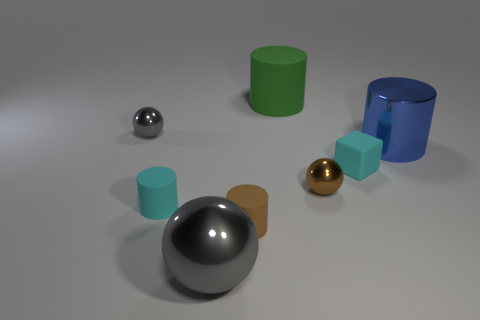What is the material of the green thing that is the same size as the metal cylinder?
Offer a very short reply. Rubber. Is there a brown metallic thing that has the same size as the brown cylinder?
Your answer should be very brief. Yes. Is the number of cyan blocks behind the small block less than the number of green cylinders?
Your answer should be compact. Yes. Are there fewer large objects that are behind the large rubber cylinder than brown metal spheres that are right of the blue metal cylinder?
Your response must be concise. No. How many spheres are either large metal things or gray shiny things?
Offer a very short reply. 2. Is the material of the small ball that is behind the shiny cylinder the same as the tiny ball on the right side of the large gray metal thing?
Make the answer very short. Yes. What is the shape of the shiny object that is the same size as the blue cylinder?
Give a very brief answer. Sphere. How many other things are the same color as the tiny matte block?
Keep it short and to the point. 1. How many blue things are either blocks or big matte objects?
Your response must be concise. 0. There is a thing in front of the brown cylinder; is it the same shape as the small metallic object in front of the small matte cube?
Give a very brief answer. Yes. 